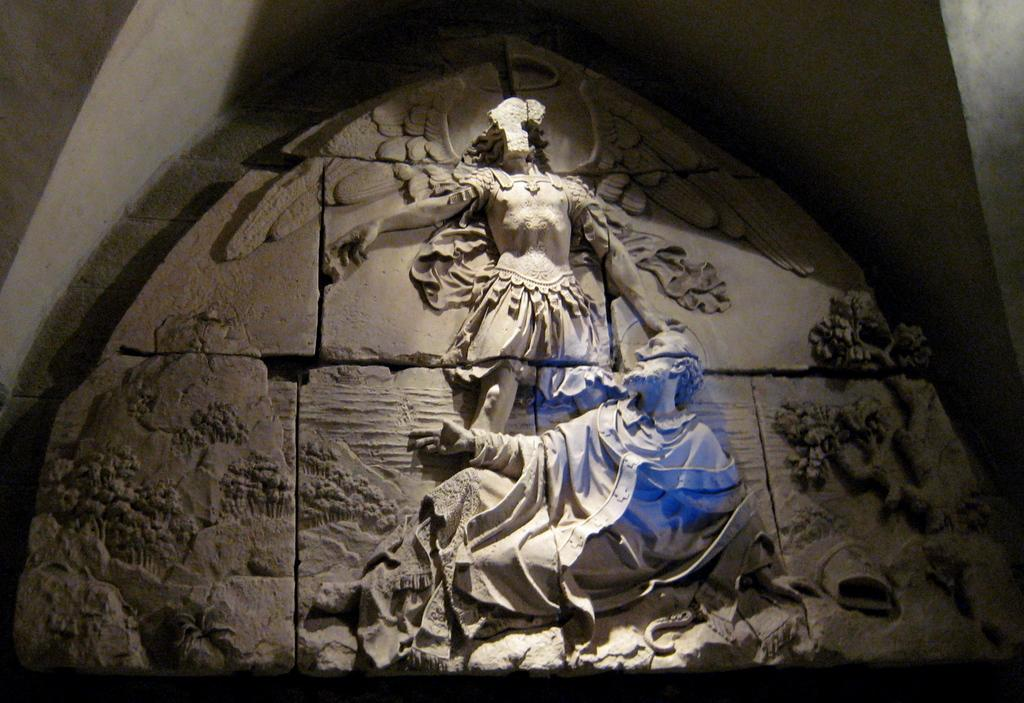What type of art is featured in the image? There are sculptures in the image. How are the sculptures positioned in relation to the wall? The sculptures are attached to the wall. What type of fabric is used to cover the snakes in the image? There are no snakes present in the image, and therefore no fabric is used to cover them. 